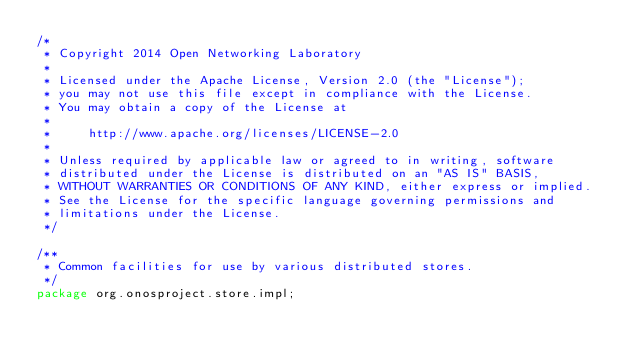Convert code to text. <code><loc_0><loc_0><loc_500><loc_500><_Java_>/*
 * Copyright 2014 Open Networking Laboratory
 *
 * Licensed under the Apache License, Version 2.0 (the "License");
 * you may not use this file except in compliance with the License.
 * You may obtain a copy of the License at
 *
 *     http://www.apache.org/licenses/LICENSE-2.0
 *
 * Unless required by applicable law or agreed to in writing, software
 * distributed under the License is distributed on an "AS IS" BASIS,
 * WITHOUT WARRANTIES OR CONDITIONS OF ANY KIND, either express or implied.
 * See the License for the specific language governing permissions and
 * limitations under the License.
 */

/**
 * Common facilities for use by various distributed stores.
 */
package org.onosproject.store.impl;
</code> 